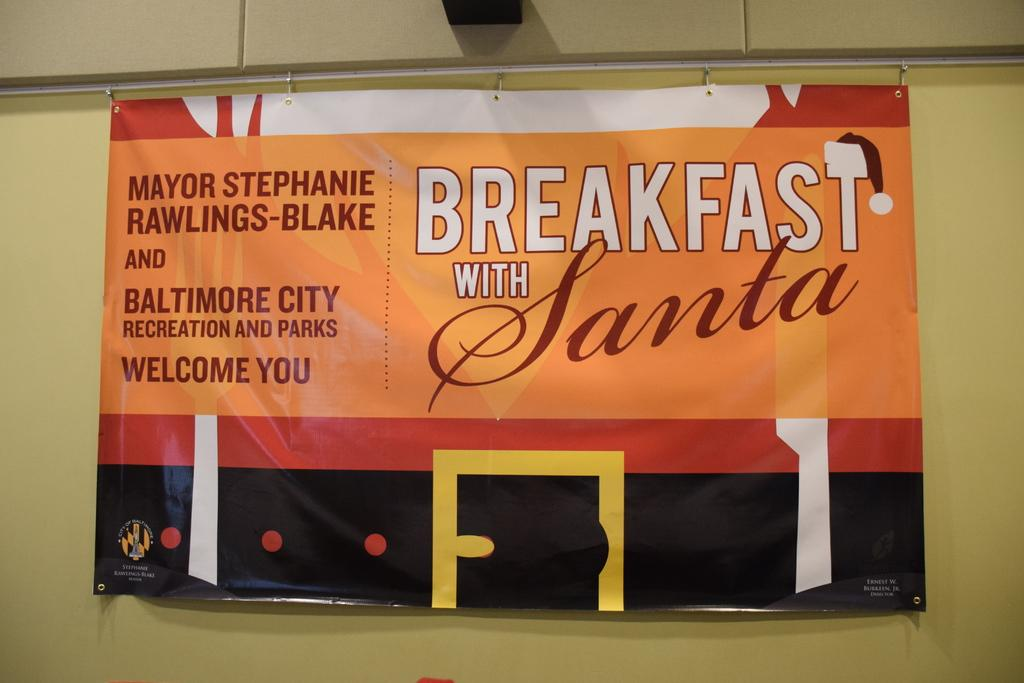<image>
Provide a brief description of the given image. An orange banner for a offer to have breakfast with Santa in Baltimore. 